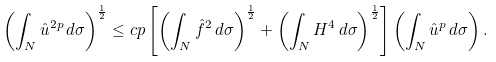<formula> <loc_0><loc_0><loc_500><loc_500>\left ( \int _ { N } \hat { u } ^ { 2 p } \, d \sigma \right ) ^ { \frac { 1 } { 2 } } \leq c p \left [ \left ( \int _ { N } \hat { f } ^ { 2 } \, d \sigma \right ) ^ { \frac { 1 } { 2 } } + \left ( \int _ { N } H ^ { 4 } \, d \sigma \right ) ^ { \frac { 1 } { 2 } } \right ] \left ( \int _ { N } \hat { u } ^ { p } \, d \sigma \right ) .</formula> 